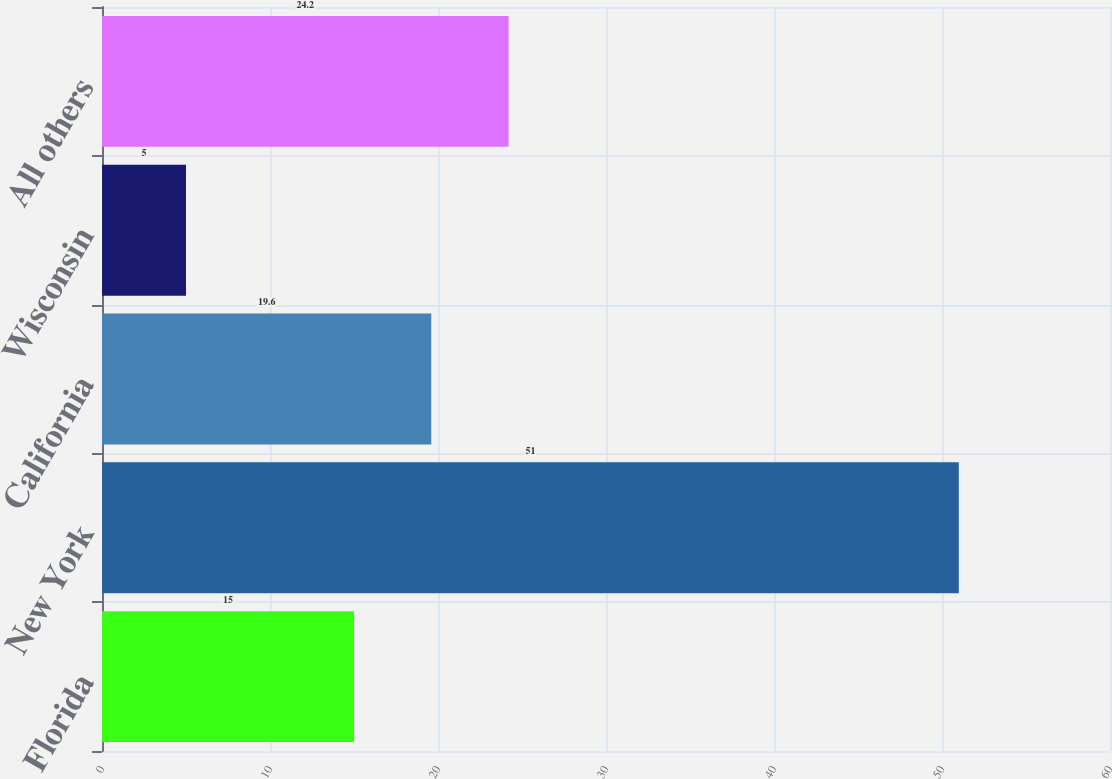Convert chart. <chart><loc_0><loc_0><loc_500><loc_500><bar_chart><fcel>Florida<fcel>New York<fcel>California<fcel>Wisconsin<fcel>All others<nl><fcel>15<fcel>51<fcel>19.6<fcel>5<fcel>24.2<nl></chart> 